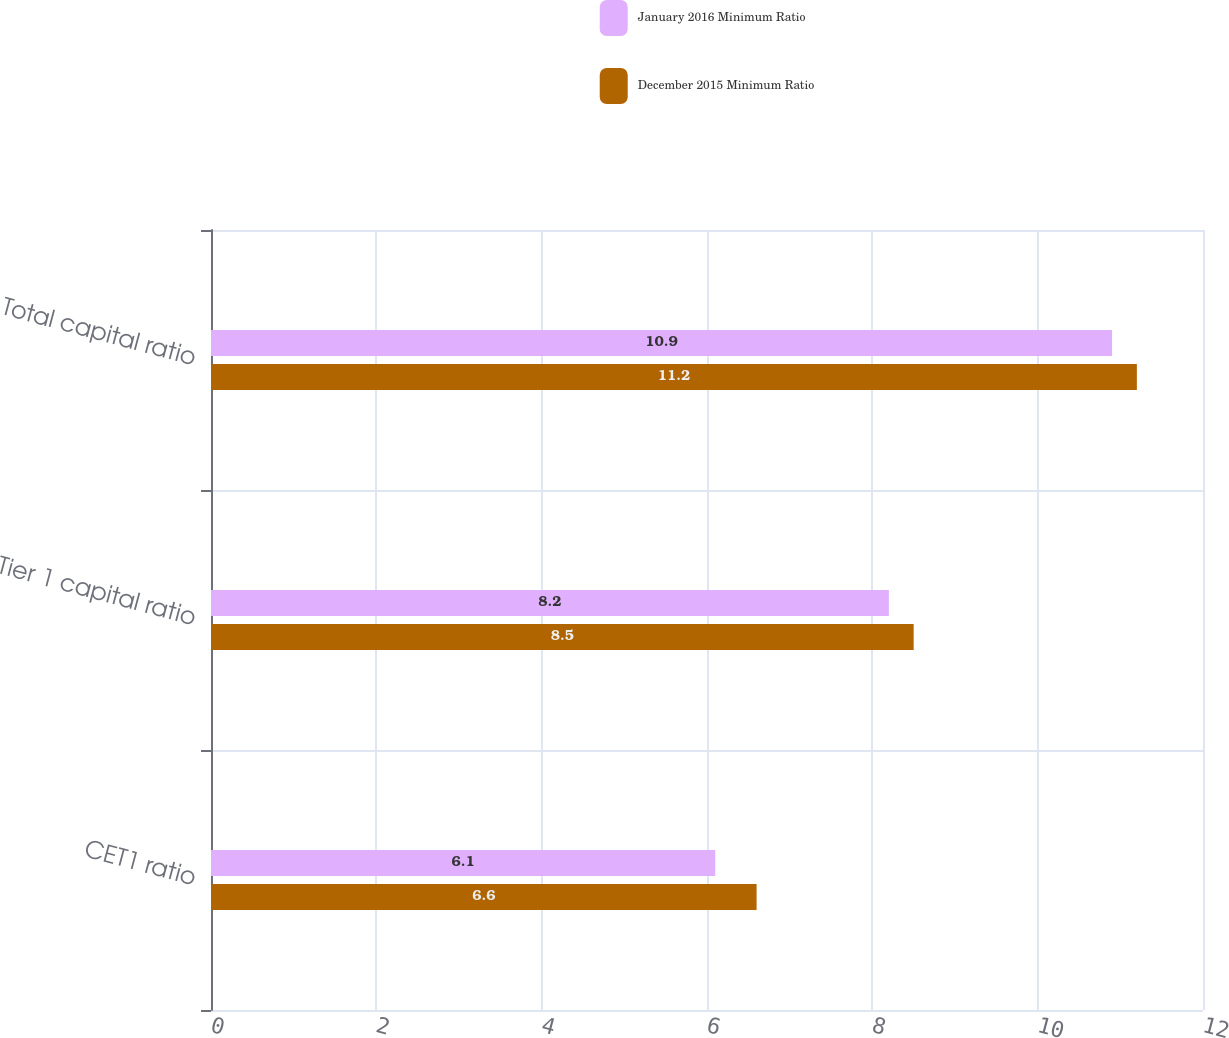Convert chart. <chart><loc_0><loc_0><loc_500><loc_500><stacked_bar_chart><ecel><fcel>CET1 ratio<fcel>Tier 1 capital ratio<fcel>Total capital ratio<nl><fcel>January 2016 Minimum Ratio<fcel>6.1<fcel>8.2<fcel>10.9<nl><fcel>December 2015 Minimum Ratio<fcel>6.6<fcel>8.5<fcel>11.2<nl></chart> 